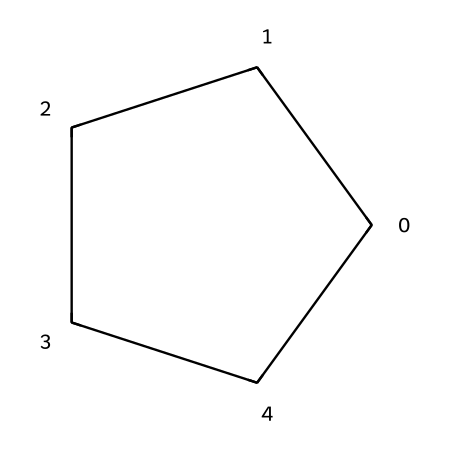What is the molecular formula of cyclopentane? The molecular formula is derived from counting the number of carbon and hydrogen atoms in the structure represented by the SMILES notation. In this case, cyclopentane contains 5 carbon atoms (C) and 10 hydrogen atoms (H), leading to the molecular formula C5H10.
Answer: C5H10 How many carbon atoms are in cyclopentane? By analyzing the structure in the SMILES notation, we identify that there are five carbon atoms involved in the ring structure of cyclopentane.
Answer: 5 What type of hydrocarbon is cyclopentane classified as? Cyclopentane is a saturated hydrocarbon with the carbon atoms forming a closed ring (cycloalkane). This classification can be determined due to its single bonds between carbon atoms and the absence of double or triple bonds.
Answer: cycloalkane What type of isomerism can cyclopentane exhibit? Cyclopentane can exhibit geometric isomerism, specifically due to its ability to form different spatial arrangements within the ring structure, although this is less pronounced in smaller cycloalkanes like cyclopentane. The nature of cyclic compounds allows for isomerism based on their symmetry and arrangement.
Answer: geometric isomerism How many hydrogen atoms are bonded to each carbon atom in cyclopentane? Each carbon in cyclopentane, being part of the saturated cycloalkane structure, is bonded to two hydrogen atoms. This is confirmed by considering the tetravalent nature of carbon and the count of hydrogen atoms after accounting for the ring structure.
Answer: 2 Is cyclopentane a polar or nonpolar molecule? Cyclopentane is a nonpolar molecule due to its symmetrical structure and the equal sharing of electrons amongst the carbon and hydrogen atoms. This leads to a lack of charge separation within the molecule.
Answer: nonpolar 